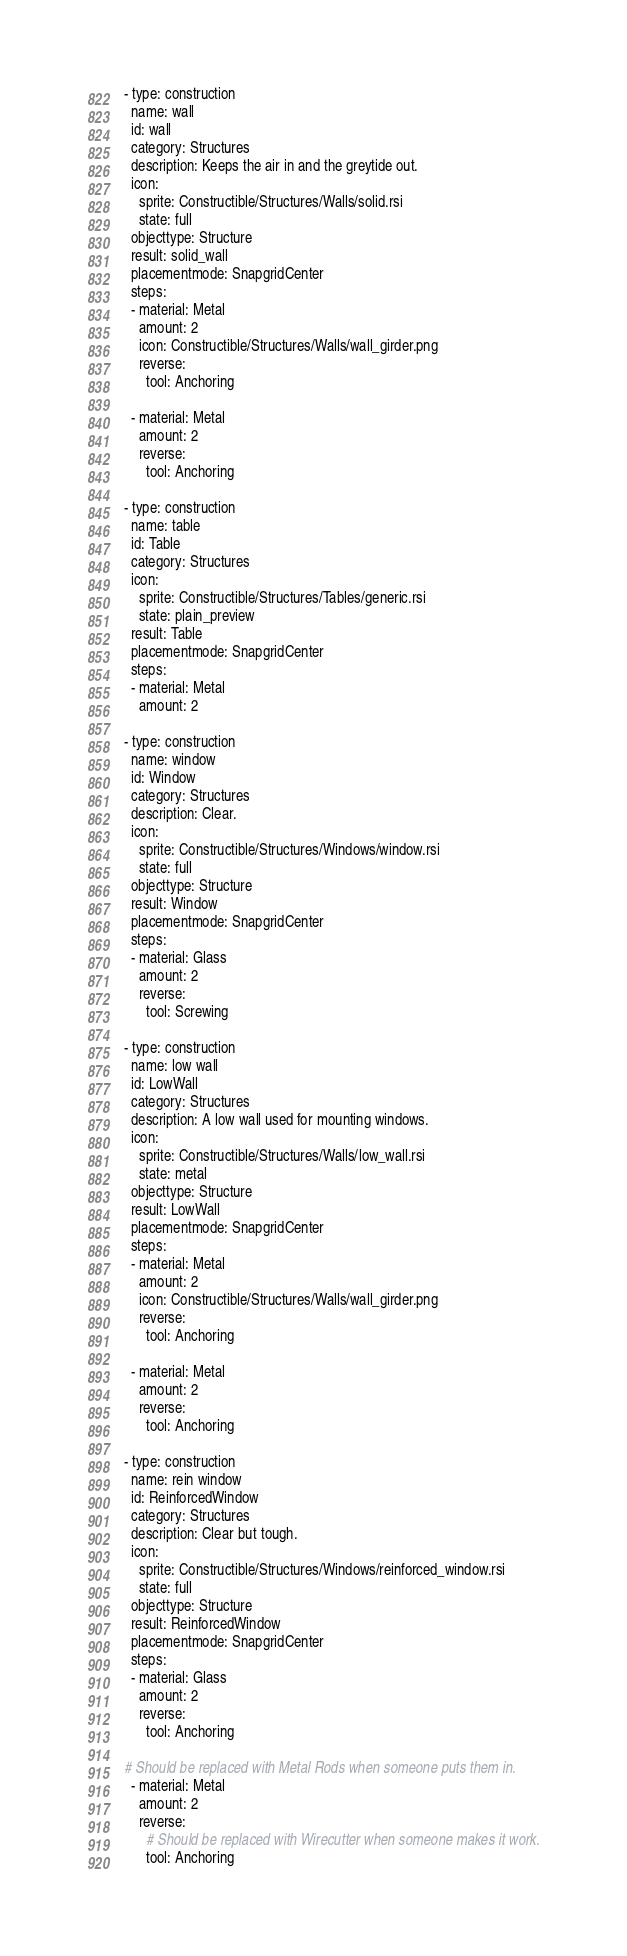<code> <loc_0><loc_0><loc_500><loc_500><_YAML_>- type: construction
  name: wall
  id: wall
  category: Structures
  description: Keeps the air in and the greytide out.
  icon:
    sprite: Constructible/Structures/Walls/solid.rsi
    state: full
  objecttype: Structure
  result: solid_wall
  placementmode: SnapgridCenter
  steps:
  - material: Metal
    amount: 2
    icon: Constructible/Structures/Walls/wall_girder.png
    reverse:
      tool: Anchoring

  - material: Metal
    amount: 2
    reverse:
      tool: Anchoring

- type: construction
  name: table
  id: Table
  category: Structures
  icon:
    sprite: Constructible/Structures/Tables/generic.rsi
    state: plain_preview
  result: Table
  placementmode: SnapgridCenter
  steps:
  - material: Metal
    amount: 2

- type: construction
  name: window
  id: Window
  category: Structures
  description: Clear.
  icon:
    sprite: Constructible/Structures/Windows/window.rsi
    state: full
  objecttype: Structure
  result: Window
  placementmode: SnapgridCenter
  steps:
  - material: Glass
    amount: 2
    reverse:
      tool: Screwing

- type: construction
  name: low wall
  id: LowWall
  category: Structures
  description: A low wall used for mounting windows.
  icon:
    sprite: Constructible/Structures/Walls/low_wall.rsi
    state: metal
  objecttype: Structure
  result: LowWall
  placementmode: SnapgridCenter
  steps:
  - material: Metal
    amount: 2
    icon: Constructible/Structures/Walls/wall_girder.png
    reverse:
      tool: Anchoring

  - material: Metal
    amount: 2
    reverse:
      tool: Anchoring

- type: construction
  name: rein window
  id: ReinforcedWindow
  category: Structures
  description: Clear but tough.
  icon:
    sprite: Constructible/Structures/Windows/reinforced_window.rsi
    state: full
  objecttype: Structure
  result: ReinforcedWindow
  placementmode: SnapgridCenter
  steps:
  - material: Glass
    amount: 2
    reverse:
      tool: Anchoring

# Should be replaced with Metal Rods when someone puts them in.
  - material: Metal
    amount: 2
    reverse:
      # Should be replaced with Wirecutter when someone makes it work.
      tool: Anchoring
</code> 